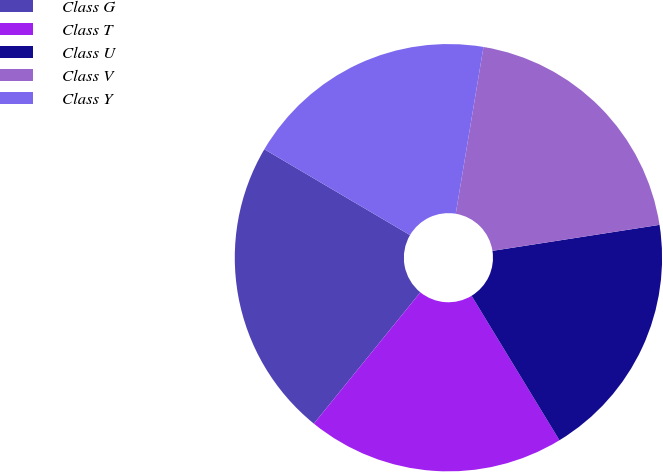Convert chart. <chart><loc_0><loc_0><loc_500><loc_500><pie_chart><fcel>Class G<fcel>Class T<fcel>Class U<fcel>Class V<fcel>Class Y<nl><fcel>22.63%<fcel>19.54%<fcel>18.76%<fcel>19.92%<fcel>19.15%<nl></chart> 